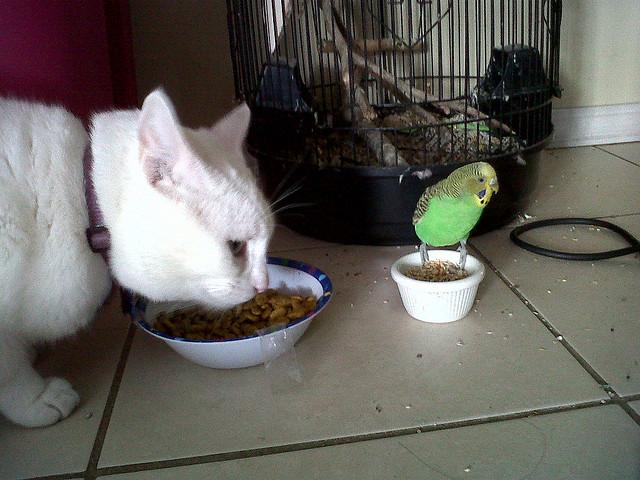Is the bird scared of the cat?
Quick response, please. No. Is that a birdcage in the background?
Concise answer only. Yes. How many pets are present?
Concise answer only. 2. 